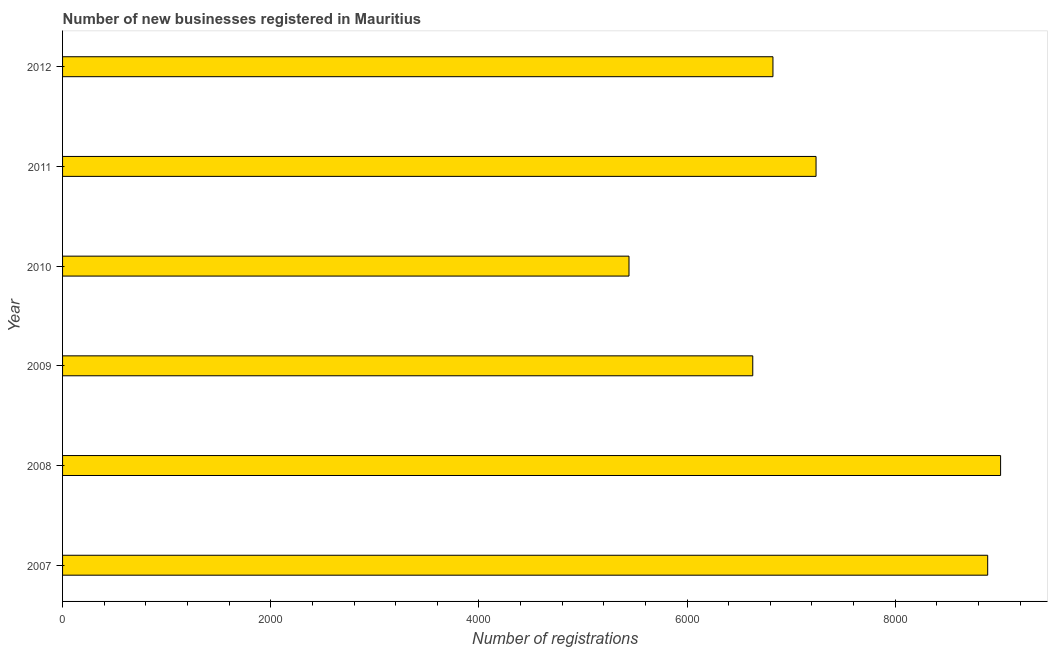Does the graph contain any zero values?
Provide a succinct answer. No. What is the title of the graph?
Provide a succinct answer. Number of new businesses registered in Mauritius. What is the label or title of the X-axis?
Offer a very short reply. Number of registrations. What is the label or title of the Y-axis?
Keep it short and to the point. Year. What is the number of new business registrations in 2009?
Keep it short and to the point. 6631. Across all years, what is the maximum number of new business registrations?
Your answer should be compact. 9012. Across all years, what is the minimum number of new business registrations?
Your response must be concise. 5442. In which year was the number of new business registrations maximum?
Offer a terse response. 2008. What is the sum of the number of new business registrations?
Give a very brief answer. 4.40e+04. What is the difference between the number of new business registrations in 2007 and 2011?
Keep it short and to the point. 1649. What is the average number of new business registrations per year?
Your response must be concise. 7339. What is the median number of new business registrations?
Your response must be concise. 7032. In how many years, is the number of new business registrations greater than 2400 ?
Offer a terse response. 6. What is the ratio of the number of new business registrations in 2008 to that in 2011?
Make the answer very short. 1.25. Is the number of new business registrations in 2010 less than that in 2011?
Keep it short and to the point. Yes. Is the difference between the number of new business registrations in 2007 and 2008 greater than the difference between any two years?
Give a very brief answer. No. What is the difference between the highest and the second highest number of new business registrations?
Ensure brevity in your answer.  124. What is the difference between the highest and the lowest number of new business registrations?
Provide a short and direct response. 3570. Are all the bars in the graph horizontal?
Your answer should be compact. Yes. How many years are there in the graph?
Your answer should be compact. 6. What is the difference between two consecutive major ticks on the X-axis?
Keep it short and to the point. 2000. What is the Number of registrations of 2007?
Make the answer very short. 8888. What is the Number of registrations of 2008?
Offer a very short reply. 9012. What is the Number of registrations of 2009?
Provide a succinct answer. 6631. What is the Number of registrations in 2010?
Keep it short and to the point. 5442. What is the Number of registrations of 2011?
Your response must be concise. 7239. What is the Number of registrations of 2012?
Provide a short and direct response. 6825. What is the difference between the Number of registrations in 2007 and 2008?
Give a very brief answer. -124. What is the difference between the Number of registrations in 2007 and 2009?
Offer a very short reply. 2257. What is the difference between the Number of registrations in 2007 and 2010?
Give a very brief answer. 3446. What is the difference between the Number of registrations in 2007 and 2011?
Provide a short and direct response. 1649. What is the difference between the Number of registrations in 2007 and 2012?
Your answer should be compact. 2063. What is the difference between the Number of registrations in 2008 and 2009?
Your response must be concise. 2381. What is the difference between the Number of registrations in 2008 and 2010?
Your answer should be very brief. 3570. What is the difference between the Number of registrations in 2008 and 2011?
Offer a very short reply. 1773. What is the difference between the Number of registrations in 2008 and 2012?
Keep it short and to the point. 2187. What is the difference between the Number of registrations in 2009 and 2010?
Offer a terse response. 1189. What is the difference between the Number of registrations in 2009 and 2011?
Provide a succinct answer. -608. What is the difference between the Number of registrations in 2009 and 2012?
Keep it short and to the point. -194. What is the difference between the Number of registrations in 2010 and 2011?
Offer a terse response. -1797. What is the difference between the Number of registrations in 2010 and 2012?
Your answer should be compact. -1383. What is the difference between the Number of registrations in 2011 and 2012?
Provide a short and direct response. 414. What is the ratio of the Number of registrations in 2007 to that in 2009?
Offer a very short reply. 1.34. What is the ratio of the Number of registrations in 2007 to that in 2010?
Keep it short and to the point. 1.63. What is the ratio of the Number of registrations in 2007 to that in 2011?
Keep it short and to the point. 1.23. What is the ratio of the Number of registrations in 2007 to that in 2012?
Your answer should be compact. 1.3. What is the ratio of the Number of registrations in 2008 to that in 2009?
Your answer should be very brief. 1.36. What is the ratio of the Number of registrations in 2008 to that in 2010?
Keep it short and to the point. 1.66. What is the ratio of the Number of registrations in 2008 to that in 2011?
Make the answer very short. 1.25. What is the ratio of the Number of registrations in 2008 to that in 2012?
Your response must be concise. 1.32. What is the ratio of the Number of registrations in 2009 to that in 2010?
Offer a terse response. 1.22. What is the ratio of the Number of registrations in 2009 to that in 2011?
Make the answer very short. 0.92. What is the ratio of the Number of registrations in 2010 to that in 2011?
Provide a short and direct response. 0.75. What is the ratio of the Number of registrations in 2010 to that in 2012?
Offer a very short reply. 0.8. What is the ratio of the Number of registrations in 2011 to that in 2012?
Provide a succinct answer. 1.06. 